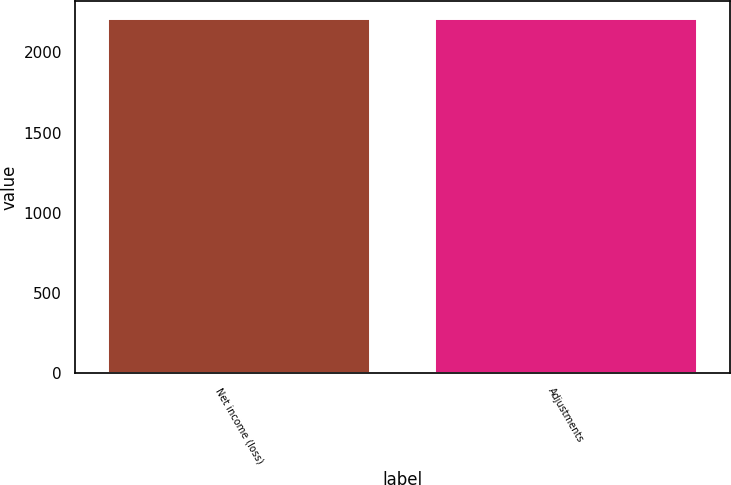<chart> <loc_0><loc_0><loc_500><loc_500><bar_chart><fcel>Net income (loss)<fcel>Adjustments<nl><fcel>2211<fcel>2211.1<nl></chart> 